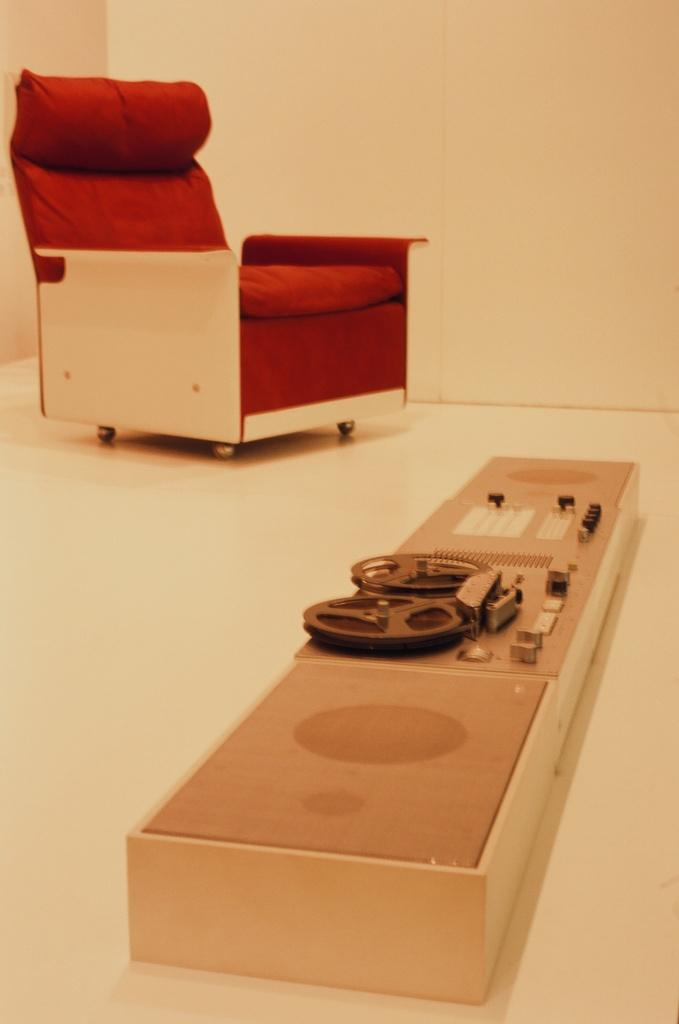What is on the floor in the image? There is an object on the floor in the image. What type of furniture is present in the image? There is a chair in the image. What can be seen in the background of the image? There is a wall in the background of the image. What type of jewel is the rat holding in the image? There is no rat or jewel present in the image. What game is being played in the image? There is no game being played in the image. 